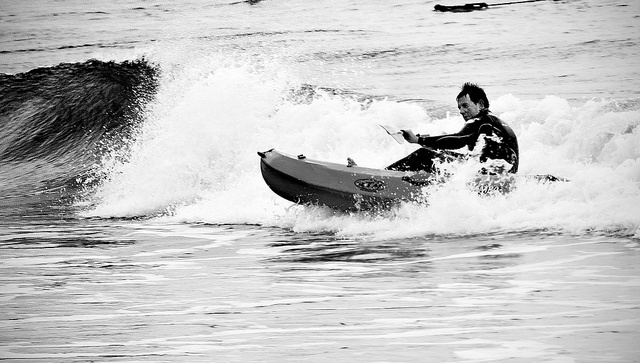Describe the objects in this image and their specific colors. I can see boat in gray, black, darkgray, and lightgray tones and people in gray, black, white, and darkgray tones in this image. 